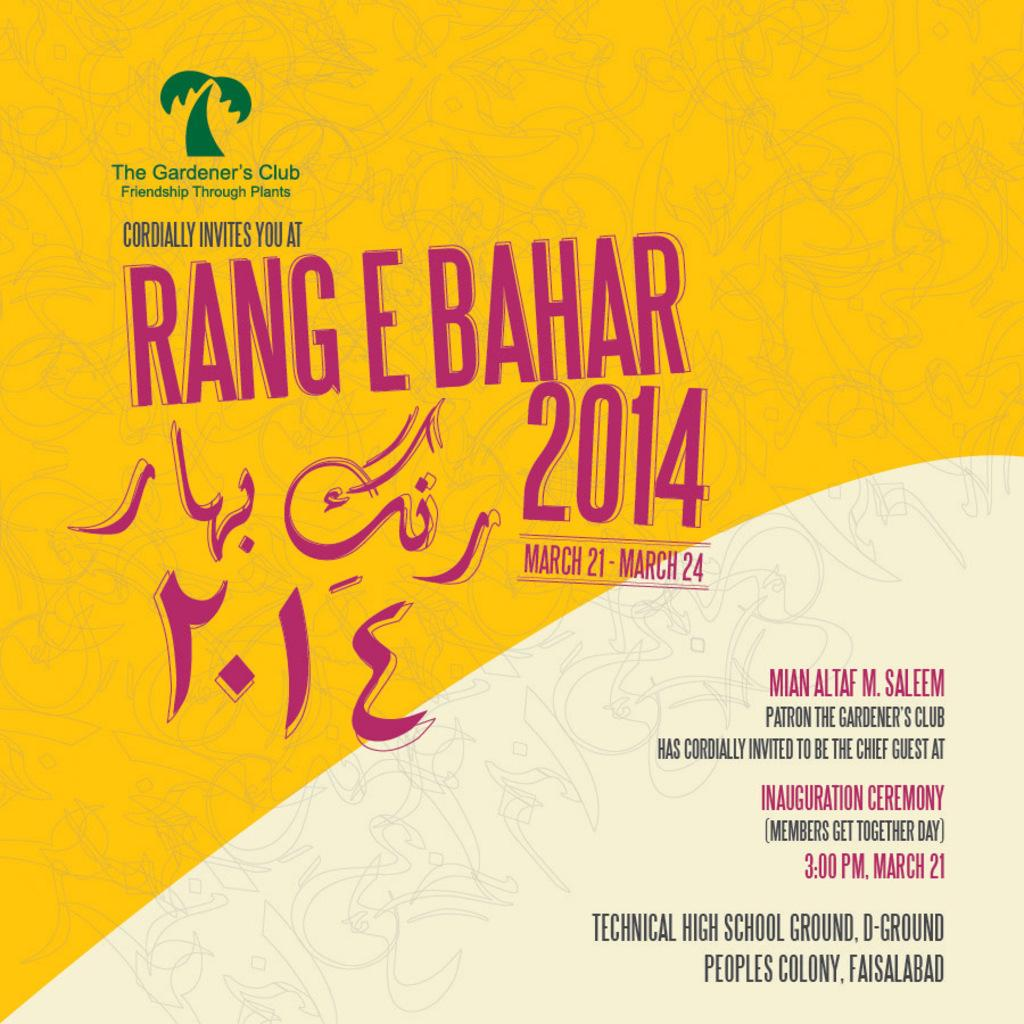<image>
Describe the image concisely. A yellow poster advertises Rang E Bahar 2014. 